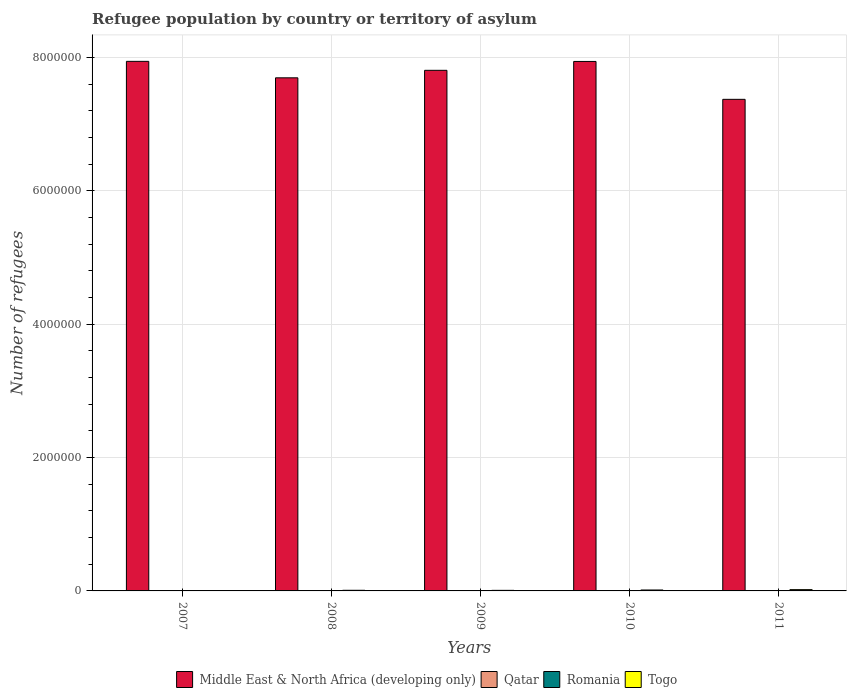How many different coloured bars are there?
Your answer should be very brief. 4. Are the number of bars per tick equal to the number of legend labels?
Ensure brevity in your answer.  Yes. What is the label of the 4th group of bars from the left?
Keep it short and to the point. 2010. In how many cases, is the number of bars for a given year not equal to the number of legend labels?
Give a very brief answer. 0. Across all years, what is the maximum number of refugees in Middle East & North Africa (developing only)?
Your answer should be very brief. 7.94e+06. Across all years, what is the minimum number of refugees in Middle East & North Africa (developing only)?
Your answer should be very brief. 7.37e+06. In which year was the number of refugees in Togo maximum?
Keep it short and to the point. 2011. What is the total number of refugees in Middle East & North Africa (developing only) in the graph?
Your response must be concise. 3.88e+07. What is the difference between the number of refugees in Qatar in 2011 and the number of refugees in Middle East & North Africa (developing only) in 2010?
Provide a short and direct response. -7.94e+06. What is the average number of refugees in Togo per year?
Your answer should be very brief. 1.05e+04. In the year 2007, what is the difference between the number of refugees in Romania and number of refugees in Middle East & North Africa (developing only)?
Provide a short and direct response. -7.94e+06. What is the ratio of the number of refugees in Qatar in 2007 to that in 2010?
Provide a short and direct response. 0.9. What is the difference between the highest and the second highest number of refugees in Qatar?
Make the answer very short. 29. What is the difference between the highest and the lowest number of refugees in Togo?
Offer a very short reply. 1.79e+04. Is it the case that in every year, the sum of the number of refugees in Qatar and number of refugees in Romania is greater than the sum of number of refugees in Middle East & North Africa (developing only) and number of refugees in Togo?
Your answer should be very brief. No. What does the 2nd bar from the left in 2011 represents?
Your response must be concise. Qatar. What does the 1st bar from the right in 2010 represents?
Keep it short and to the point. Togo. Is it the case that in every year, the sum of the number of refugees in Togo and number of refugees in Middle East & North Africa (developing only) is greater than the number of refugees in Romania?
Offer a terse response. Yes. What is the difference between two consecutive major ticks on the Y-axis?
Offer a terse response. 2.00e+06. Does the graph contain any zero values?
Your answer should be compact. No. What is the title of the graph?
Your answer should be very brief. Refugee population by country or territory of asylum. Does "Namibia" appear as one of the legend labels in the graph?
Offer a terse response. No. What is the label or title of the X-axis?
Your response must be concise. Years. What is the label or title of the Y-axis?
Your answer should be very brief. Number of refugees. What is the Number of refugees in Middle East & North Africa (developing only) in 2007?
Offer a terse response. 7.94e+06. What is the Number of refugees of Qatar in 2007?
Ensure brevity in your answer.  46. What is the Number of refugees in Romania in 2007?
Make the answer very short. 1757. What is the Number of refugees of Togo in 2007?
Make the answer very short. 1328. What is the Number of refugees of Middle East & North Africa (developing only) in 2008?
Offer a very short reply. 7.70e+06. What is the Number of refugees of Romania in 2008?
Provide a short and direct response. 1596. What is the Number of refugees in Togo in 2008?
Provide a short and direct response. 9377. What is the Number of refugees of Middle East & North Africa (developing only) in 2009?
Make the answer very short. 7.81e+06. What is the Number of refugees of Romania in 2009?
Your answer should be compact. 1069. What is the Number of refugees in Togo in 2009?
Ensure brevity in your answer.  8531. What is the Number of refugees of Middle East & North Africa (developing only) in 2010?
Offer a terse response. 7.94e+06. What is the Number of refugees in Romania in 2010?
Keep it short and to the point. 1021. What is the Number of refugees in Togo in 2010?
Ensure brevity in your answer.  1.41e+04. What is the Number of refugees in Middle East & North Africa (developing only) in 2011?
Your answer should be very brief. 7.37e+06. What is the Number of refugees of Qatar in 2011?
Provide a short and direct response. 80. What is the Number of refugees of Romania in 2011?
Provide a short and direct response. 1005. What is the Number of refugees of Togo in 2011?
Give a very brief answer. 1.93e+04. Across all years, what is the maximum Number of refugees of Middle East & North Africa (developing only)?
Your answer should be compact. 7.94e+06. Across all years, what is the maximum Number of refugees in Romania?
Keep it short and to the point. 1757. Across all years, what is the maximum Number of refugees of Togo?
Give a very brief answer. 1.93e+04. Across all years, what is the minimum Number of refugees of Middle East & North Africa (developing only)?
Your answer should be compact. 7.37e+06. Across all years, what is the minimum Number of refugees of Qatar?
Offer a very short reply. 13. Across all years, what is the minimum Number of refugees of Romania?
Your answer should be very brief. 1005. Across all years, what is the minimum Number of refugees of Togo?
Your response must be concise. 1328. What is the total Number of refugees of Middle East & North Africa (developing only) in the graph?
Your answer should be compact. 3.88e+07. What is the total Number of refugees in Qatar in the graph?
Provide a short and direct response. 219. What is the total Number of refugees in Romania in the graph?
Provide a short and direct response. 6448. What is the total Number of refugees of Togo in the graph?
Provide a succinct answer. 5.26e+04. What is the difference between the Number of refugees in Middle East & North Africa (developing only) in 2007 and that in 2008?
Offer a very short reply. 2.47e+05. What is the difference between the Number of refugees in Qatar in 2007 and that in 2008?
Provide a succinct answer. 33. What is the difference between the Number of refugees in Romania in 2007 and that in 2008?
Your answer should be compact. 161. What is the difference between the Number of refugees in Togo in 2007 and that in 2008?
Make the answer very short. -8049. What is the difference between the Number of refugees of Middle East & North Africa (developing only) in 2007 and that in 2009?
Provide a succinct answer. 1.34e+05. What is the difference between the Number of refugees in Romania in 2007 and that in 2009?
Offer a very short reply. 688. What is the difference between the Number of refugees of Togo in 2007 and that in 2009?
Offer a terse response. -7203. What is the difference between the Number of refugees of Middle East & North Africa (developing only) in 2007 and that in 2010?
Your answer should be very brief. 1464. What is the difference between the Number of refugees in Qatar in 2007 and that in 2010?
Your answer should be compact. -5. What is the difference between the Number of refugees in Romania in 2007 and that in 2010?
Keep it short and to the point. 736. What is the difference between the Number of refugees in Togo in 2007 and that in 2010?
Your response must be concise. -1.27e+04. What is the difference between the Number of refugees of Middle East & North Africa (developing only) in 2007 and that in 2011?
Give a very brief answer. 5.70e+05. What is the difference between the Number of refugees of Qatar in 2007 and that in 2011?
Offer a terse response. -34. What is the difference between the Number of refugees of Romania in 2007 and that in 2011?
Your answer should be very brief. 752. What is the difference between the Number of refugees of Togo in 2007 and that in 2011?
Provide a succinct answer. -1.79e+04. What is the difference between the Number of refugees of Middle East & North Africa (developing only) in 2008 and that in 2009?
Offer a terse response. -1.13e+05. What is the difference between the Number of refugees of Romania in 2008 and that in 2009?
Offer a terse response. 527. What is the difference between the Number of refugees of Togo in 2008 and that in 2009?
Make the answer very short. 846. What is the difference between the Number of refugees of Middle East & North Africa (developing only) in 2008 and that in 2010?
Offer a terse response. -2.45e+05. What is the difference between the Number of refugees of Qatar in 2008 and that in 2010?
Offer a very short reply. -38. What is the difference between the Number of refugees of Romania in 2008 and that in 2010?
Provide a short and direct response. 575. What is the difference between the Number of refugees of Togo in 2008 and that in 2010?
Ensure brevity in your answer.  -4674. What is the difference between the Number of refugees in Middle East & North Africa (developing only) in 2008 and that in 2011?
Keep it short and to the point. 3.23e+05. What is the difference between the Number of refugees of Qatar in 2008 and that in 2011?
Ensure brevity in your answer.  -67. What is the difference between the Number of refugees in Romania in 2008 and that in 2011?
Ensure brevity in your answer.  591. What is the difference between the Number of refugees in Togo in 2008 and that in 2011?
Your answer should be very brief. -9893. What is the difference between the Number of refugees of Middle East & North Africa (developing only) in 2009 and that in 2010?
Provide a short and direct response. -1.33e+05. What is the difference between the Number of refugees in Togo in 2009 and that in 2010?
Your response must be concise. -5520. What is the difference between the Number of refugees in Middle East & North Africa (developing only) in 2009 and that in 2011?
Ensure brevity in your answer.  4.35e+05. What is the difference between the Number of refugees of Qatar in 2009 and that in 2011?
Ensure brevity in your answer.  -51. What is the difference between the Number of refugees in Togo in 2009 and that in 2011?
Your response must be concise. -1.07e+04. What is the difference between the Number of refugees in Middle East & North Africa (developing only) in 2010 and that in 2011?
Provide a short and direct response. 5.68e+05. What is the difference between the Number of refugees in Romania in 2010 and that in 2011?
Make the answer very short. 16. What is the difference between the Number of refugees in Togo in 2010 and that in 2011?
Offer a terse response. -5219. What is the difference between the Number of refugees of Middle East & North Africa (developing only) in 2007 and the Number of refugees of Qatar in 2008?
Ensure brevity in your answer.  7.94e+06. What is the difference between the Number of refugees in Middle East & North Africa (developing only) in 2007 and the Number of refugees in Romania in 2008?
Keep it short and to the point. 7.94e+06. What is the difference between the Number of refugees of Middle East & North Africa (developing only) in 2007 and the Number of refugees of Togo in 2008?
Ensure brevity in your answer.  7.93e+06. What is the difference between the Number of refugees of Qatar in 2007 and the Number of refugees of Romania in 2008?
Offer a very short reply. -1550. What is the difference between the Number of refugees in Qatar in 2007 and the Number of refugees in Togo in 2008?
Give a very brief answer. -9331. What is the difference between the Number of refugees of Romania in 2007 and the Number of refugees of Togo in 2008?
Provide a succinct answer. -7620. What is the difference between the Number of refugees in Middle East & North Africa (developing only) in 2007 and the Number of refugees in Qatar in 2009?
Make the answer very short. 7.94e+06. What is the difference between the Number of refugees in Middle East & North Africa (developing only) in 2007 and the Number of refugees in Romania in 2009?
Provide a short and direct response. 7.94e+06. What is the difference between the Number of refugees of Middle East & North Africa (developing only) in 2007 and the Number of refugees of Togo in 2009?
Offer a very short reply. 7.94e+06. What is the difference between the Number of refugees in Qatar in 2007 and the Number of refugees in Romania in 2009?
Make the answer very short. -1023. What is the difference between the Number of refugees of Qatar in 2007 and the Number of refugees of Togo in 2009?
Ensure brevity in your answer.  -8485. What is the difference between the Number of refugees in Romania in 2007 and the Number of refugees in Togo in 2009?
Make the answer very short. -6774. What is the difference between the Number of refugees of Middle East & North Africa (developing only) in 2007 and the Number of refugees of Qatar in 2010?
Your response must be concise. 7.94e+06. What is the difference between the Number of refugees of Middle East & North Africa (developing only) in 2007 and the Number of refugees of Romania in 2010?
Provide a short and direct response. 7.94e+06. What is the difference between the Number of refugees of Middle East & North Africa (developing only) in 2007 and the Number of refugees of Togo in 2010?
Keep it short and to the point. 7.93e+06. What is the difference between the Number of refugees of Qatar in 2007 and the Number of refugees of Romania in 2010?
Your answer should be very brief. -975. What is the difference between the Number of refugees in Qatar in 2007 and the Number of refugees in Togo in 2010?
Offer a terse response. -1.40e+04. What is the difference between the Number of refugees of Romania in 2007 and the Number of refugees of Togo in 2010?
Provide a short and direct response. -1.23e+04. What is the difference between the Number of refugees of Middle East & North Africa (developing only) in 2007 and the Number of refugees of Qatar in 2011?
Provide a short and direct response. 7.94e+06. What is the difference between the Number of refugees of Middle East & North Africa (developing only) in 2007 and the Number of refugees of Romania in 2011?
Your answer should be compact. 7.94e+06. What is the difference between the Number of refugees of Middle East & North Africa (developing only) in 2007 and the Number of refugees of Togo in 2011?
Make the answer very short. 7.92e+06. What is the difference between the Number of refugees of Qatar in 2007 and the Number of refugees of Romania in 2011?
Ensure brevity in your answer.  -959. What is the difference between the Number of refugees of Qatar in 2007 and the Number of refugees of Togo in 2011?
Your answer should be very brief. -1.92e+04. What is the difference between the Number of refugees of Romania in 2007 and the Number of refugees of Togo in 2011?
Your response must be concise. -1.75e+04. What is the difference between the Number of refugees of Middle East & North Africa (developing only) in 2008 and the Number of refugees of Qatar in 2009?
Ensure brevity in your answer.  7.70e+06. What is the difference between the Number of refugees of Middle East & North Africa (developing only) in 2008 and the Number of refugees of Romania in 2009?
Offer a terse response. 7.70e+06. What is the difference between the Number of refugees of Middle East & North Africa (developing only) in 2008 and the Number of refugees of Togo in 2009?
Your answer should be compact. 7.69e+06. What is the difference between the Number of refugees of Qatar in 2008 and the Number of refugees of Romania in 2009?
Give a very brief answer. -1056. What is the difference between the Number of refugees of Qatar in 2008 and the Number of refugees of Togo in 2009?
Provide a short and direct response. -8518. What is the difference between the Number of refugees in Romania in 2008 and the Number of refugees in Togo in 2009?
Offer a terse response. -6935. What is the difference between the Number of refugees of Middle East & North Africa (developing only) in 2008 and the Number of refugees of Qatar in 2010?
Provide a short and direct response. 7.70e+06. What is the difference between the Number of refugees in Middle East & North Africa (developing only) in 2008 and the Number of refugees in Romania in 2010?
Offer a terse response. 7.70e+06. What is the difference between the Number of refugees in Middle East & North Africa (developing only) in 2008 and the Number of refugees in Togo in 2010?
Your answer should be very brief. 7.68e+06. What is the difference between the Number of refugees of Qatar in 2008 and the Number of refugees of Romania in 2010?
Your answer should be very brief. -1008. What is the difference between the Number of refugees in Qatar in 2008 and the Number of refugees in Togo in 2010?
Provide a succinct answer. -1.40e+04. What is the difference between the Number of refugees of Romania in 2008 and the Number of refugees of Togo in 2010?
Make the answer very short. -1.25e+04. What is the difference between the Number of refugees of Middle East & North Africa (developing only) in 2008 and the Number of refugees of Qatar in 2011?
Make the answer very short. 7.70e+06. What is the difference between the Number of refugees of Middle East & North Africa (developing only) in 2008 and the Number of refugees of Romania in 2011?
Provide a succinct answer. 7.70e+06. What is the difference between the Number of refugees of Middle East & North Africa (developing only) in 2008 and the Number of refugees of Togo in 2011?
Your response must be concise. 7.68e+06. What is the difference between the Number of refugees of Qatar in 2008 and the Number of refugees of Romania in 2011?
Your answer should be compact. -992. What is the difference between the Number of refugees of Qatar in 2008 and the Number of refugees of Togo in 2011?
Provide a short and direct response. -1.93e+04. What is the difference between the Number of refugees of Romania in 2008 and the Number of refugees of Togo in 2011?
Offer a terse response. -1.77e+04. What is the difference between the Number of refugees of Middle East & North Africa (developing only) in 2009 and the Number of refugees of Qatar in 2010?
Keep it short and to the point. 7.81e+06. What is the difference between the Number of refugees of Middle East & North Africa (developing only) in 2009 and the Number of refugees of Romania in 2010?
Ensure brevity in your answer.  7.81e+06. What is the difference between the Number of refugees of Middle East & North Africa (developing only) in 2009 and the Number of refugees of Togo in 2010?
Your answer should be compact. 7.80e+06. What is the difference between the Number of refugees of Qatar in 2009 and the Number of refugees of Romania in 2010?
Offer a very short reply. -992. What is the difference between the Number of refugees in Qatar in 2009 and the Number of refugees in Togo in 2010?
Your response must be concise. -1.40e+04. What is the difference between the Number of refugees in Romania in 2009 and the Number of refugees in Togo in 2010?
Provide a short and direct response. -1.30e+04. What is the difference between the Number of refugees in Middle East & North Africa (developing only) in 2009 and the Number of refugees in Qatar in 2011?
Ensure brevity in your answer.  7.81e+06. What is the difference between the Number of refugees in Middle East & North Africa (developing only) in 2009 and the Number of refugees in Romania in 2011?
Your answer should be compact. 7.81e+06. What is the difference between the Number of refugees in Middle East & North Africa (developing only) in 2009 and the Number of refugees in Togo in 2011?
Keep it short and to the point. 7.79e+06. What is the difference between the Number of refugees in Qatar in 2009 and the Number of refugees in Romania in 2011?
Your answer should be very brief. -976. What is the difference between the Number of refugees in Qatar in 2009 and the Number of refugees in Togo in 2011?
Ensure brevity in your answer.  -1.92e+04. What is the difference between the Number of refugees in Romania in 2009 and the Number of refugees in Togo in 2011?
Provide a succinct answer. -1.82e+04. What is the difference between the Number of refugees of Middle East & North Africa (developing only) in 2010 and the Number of refugees of Qatar in 2011?
Offer a terse response. 7.94e+06. What is the difference between the Number of refugees of Middle East & North Africa (developing only) in 2010 and the Number of refugees of Romania in 2011?
Your response must be concise. 7.94e+06. What is the difference between the Number of refugees of Middle East & North Africa (developing only) in 2010 and the Number of refugees of Togo in 2011?
Keep it short and to the point. 7.92e+06. What is the difference between the Number of refugees in Qatar in 2010 and the Number of refugees in Romania in 2011?
Your response must be concise. -954. What is the difference between the Number of refugees of Qatar in 2010 and the Number of refugees of Togo in 2011?
Your answer should be very brief. -1.92e+04. What is the difference between the Number of refugees of Romania in 2010 and the Number of refugees of Togo in 2011?
Give a very brief answer. -1.82e+04. What is the average Number of refugees in Middle East & North Africa (developing only) per year?
Provide a succinct answer. 7.75e+06. What is the average Number of refugees in Qatar per year?
Provide a succinct answer. 43.8. What is the average Number of refugees of Romania per year?
Your answer should be very brief. 1289.6. What is the average Number of refugees of Togo per year?
Your answer should be very brief. 1.05e+04. In the year 2007, what is the difference between the Number of refugees in Middle East & North Africa (developing only) and Number of refugees in Qatar?
Offer a terse response. 7.94e+06. In the year 2007, what is the difference between the Number of refugees in Middle East & North Africa (developing only) and Number of refugees in Romania?
Provide a succinct answer. 7.94e+06. In the year 2007, what is the difference between the Number of refugees in Middle East & North Africa (developing only) and Number of refugees in Togo?
Your response must be concise. 7.94e+06. In the year 2007, what is the difference between the Number of refugees in Qatar and Number of refugees in Romania?
Ensure brevity in your answer.  -1711. In the year 2007, what is the difference between the Number of refugees in Qatar and Number of refugees in Togo?
Provide a succinct answer. -1282. In the year 2007, what is the difference between the Number of refugees in Romania and Number of refugees in Togo?
Provide a succinct answer. 429. In the year 2008, what is the difference between the Number of refugees in Middle East & North Africa (developing only) and Number of refugees in Qatar?
Keep it short and to the point. 7.70e+06. In the year 2008, what is the difference between the Number of refugees of Middle East & North Africa (developing only) and Number of refugees of Romania?
Give a very brief answer. 7.70e+06. In the year 2008, what is the difference between the Number of refugees of Middle East & North Africa (developing only) and Number of refugees of Togo?
Your answer should be very brief. 7.69e+06. In the year 2008, what is the difference between the Number of refugees of Qatar and Number of refugees of Romania?
Provide a succinct answer. -1583. In the year 2008, what is the difference between the Number of refugees of Qatar and Number of refugees of Togo?
Offer a terse response. -9364. In the year 2008, what is the difference between the Number of refugees of Romania and Number of refugees of Togo?
Offer a very short reply. -7781. In the year 2009, what is the difference between the Number of refugees of Middle East & North Africa (developing only) and Number of refugees of Qatar?
Give a very brief answer. 7.81e+06. In the year 2009, what is the difference between the Number of refugees in Middle East & North Africa (developing only) and Number of refugees in Romania?
Make the answer very short. 7.81e+06. In the year 2009, what is the difference between the Number of refugees of Middle East & North Africa (developing only) and Number of refugees of Togo?
Your answer should be very brief. 7.80e+06. In the year 2009, what is the difference between the Number of refugees in Qatar and Number of refugees in Romania?
Make the answer very short. -1040. In the year 2009, what is the difference between the Number of refugees in Qatar and Number of refugees in Togo?
Give a very brief answer. -8502. In the year 2009, what is the difference between the Number of refugees of Romania and Number of refugees of Togo?
Your response must be concise. -7462. In the year 2010, what is the difference between the Number of refugees of Middle East & North Africa (developing only) and Number of refugees of Qatar?
Your response must be concise. 7.94e+06. In the year 2010, what is the difference between the Number of refugees of Middle East & North Africa (developing only) and Number of refugees of Romania?
Provide a succinct answer. 7.94e+06. In the year 2010, what is the difference between the Number of refugees in Middle East & North Africa (developing only) and Number of refugees in Togo?
Give a very brief answer. 7.93e+06. In the year 2010, what is the difference between the Number of refugees of Qatar and Number of refugees of Romania?
Provide a succinct answer. -970. In the year 2010, what is the difference between the Number of refugees of Qatar and Number of refugees of Togo?
Keep it short and to the point. -1.40e+04. In the year 2010, what is the difference between the Number of refugees of Romania and Number of refugees of Togo?
Your answer should be compact. -1.30e+04. In the year 2011, what is the difference between the Number of refugees of Middle East & North Africa (developing only) and Number of refugees of Qatar?
Your answer should be very brief. 7.37e+06. In the year 2011, what is the difference between the Number of refugees in Middle East & North Africa (developing only) and Number of refugees in Romania?
Your answer should be compact. 7.37e+06. In the year 2011, what is the difference between the Number of refugees of Middle East & North Africa (developing only) and Number of refugees of Togo?
Give a very brief answer. 7.35e+06. In the year 2011, what is the difference between the Number of refugees of Qatar and Number of refugees of Romania?
Make the answer very short. -925. In the year 2011, what is the difference between the Number of refugees in Qatar and Number of refugees in Togo?
Give a very brief answer. -1.92e+04. In the year 2011, what is the difference between the Number of refugees of Romania and Number of refugees of Togo?
Your answer should be compact. -1.83e+04. What is the ratio of the Number of refugees of Middle East & North Africa (developing only) in 2007 to that in 2008?
Offer a very short reply. 1.03. What is the ratio of the Number of refugees in Qatar in 2007 to that in 2008?
Keep it short and to the point. 3.54. What is the ratio of the Number of refugees of Romania in 2007 to that in 2008?
Provide a short and direct response. 1.1. What is the ratio of the Number of refugees of Togo in 2007 to that in 2008?
Your response must be concise. 0.14. What is the ratio of the Number of refugees in Middle East & North Africa (developing only) in 2007 to that in 2009?
Ensure brevity in your answer.  1.02. What is the ratio of the Number of refugees of Qatar in 2007 to that in 2009?
Make the answer very short. 1.59. What is the ratio of the Number of refugees in Romania in 2007 to that in 2009?
Provide a short and direct response. 1.64. What is the ratio of the Number of refugees of Togo in 2007 to that in 2009?
Keep it short and to the point. 0.16. What is the ratio of the Number of refugees in Qatar in 2007 to that in 2010?
Keep it short and to the point. 0.9. What is the ratio of the Number of refugees of Romania in 2007 to that in 2010?
Make the answer very short. 1.72. What is the ratio of the Number of refugees of Togo in 2007 to that in 2010?
Your response must be concise. 0.09. What is the ratio of the Number of refugees in Middle East & North Africa (developing only) in 2007 to that in 2011?
Offer a very short reply. 1.08. What is the ratio of the Number of refugees of Qatar in 2007 to that in 2011?
Give a very brief answer. 0.57. What is the ratio of the Number of refugees of Romania in 2007 to that in 2011?
Provide a succinct answer. 1.75. What is the ratio of the Number of refugees in Togo in 2007 to that in 2011?
Ensure brevity in your answer.  0.07. What is the ratio of the Number of refugees in Middle East & North Africa (developing only) in 2008 to that in 2009?
Ensure brevity in your answer.  0.99. What is the ratio of the Number of refugees of Qatar in 2008 to that in 2009?
Offer a terse response. 0.45. What is the ratio of the Number of refugees of Romania in 2008 to that in 2009?
Your answer should be very brief. 1.49. What is the ratio of the Number of refugees in Togo in 2008 to that in 2009?
Your answer should be compact. 1.1. What is the ratio of the Number of refugees in Middle East & North Africa (developing only) in 2008 to that in 2010?
Provide a short and direct response. 0.97. What is the ratio of the Number of refugees of Qatar in 2008 to that in 2010?
Your answer should be very brief. 0.25. What is the ratio of the Number of refugees of Romania in 2008 to that in 2010?
Offer a very short reply. 1.56. What is the ratio of the Number of refugees of Togo in 2008 to that in 2010?
Offer a very short reply. 0.67. What is the ratio of the Number of refugees of Middle East & North Africa (developing only) in 2008 to that in 2011?
Make the answer very short. 1.04. What is the ratio of the Number of refugees of Qatar in 2008 to that in 2011?
Offer a terse response. 0.16. What is the ratio of the Number of refugees of Romania in 2008 to that in 2011?
Ensure brevity in your answer.  1.59. What is the ratio of the Number of refugees of Togo in 2008 to that in 2011?
Your answer should be compact. 0.49. What is the ratio of the Number of refugees of Middle East & North Africa (developing only) in 2009 to that in 2010?
Give a very brief answer. 0.98. What is the ratio of the Number of refugees of Qatar in 2009 to that in 2010?
Keep it short and to the point. 0.57. What is the ratio of the Number of refugees of Romania in 2009 to that in 2010?
Your answer should be very brief. 1.05. What is the ratio of the Number of refugees of Togo in 2009 to that in 2010?
Offer a very short reply. 0.61. What is the ratio of the Number of refugees of Middle East & North Africa (developing only) in 2009 to that in 2011?
Keep it short and to the point. 1.06. What is the ratio of the Number of refugees in Qatar in 2009 to that in 2011?
Keep it short and to the point. 0.36. What is the ratio of the Number of refugees in Romania in 2009 to that in 2011?
Provide a succinct answer. 1.06. What is the ratio of the Number of refugees of Togo in 2009 to that in 2011?
Offer a terse response. 0.44. What is the ratio of the Number of refugees in Middle East & North Africa (developing only) in 2010 to that in 2011?
Provide a succinct answer. 1.08. What is the ratio of the Number of refugees of Qatar in 2010 to that in 2011?
Give a very brief answer. 0.64. What is the ratio of the Number of refugees of Romania in 2010 to that in 2011?
Offer a terse response. 1.02. What is the ratio of the Number of refugees in Togo in 2010 to that in 2011?
Offer a terse response. 0.73. What is the difference between the highest and the second highest Number of refugees in Middle East & North Africa (developing only)?
Provide a short and direct response. 1464. What is the difference between the highest and the second highest Number of refugees in Romania?
Your response must be concise. 161. What is the difference between the highest and the second highest Number of refugees of Togo?
Give a very brief answer. 5219. What is the difference between the highest and the lowest Number of refugees of Middle East & North Africa (developing only)?
Give a very brief answer. 5.70e+05. What is the difference between the highest and the lowest Number of refugees in Qatar?
Keep it short and to the point. 67. What is the difference between the highest and the lowest Number of refugees in Romania?
Provide a short and direct response. 752. What is the difference between the highest and the lowest Number of refugees of Togo?
Your answer should be compact. 1.79e+04. 